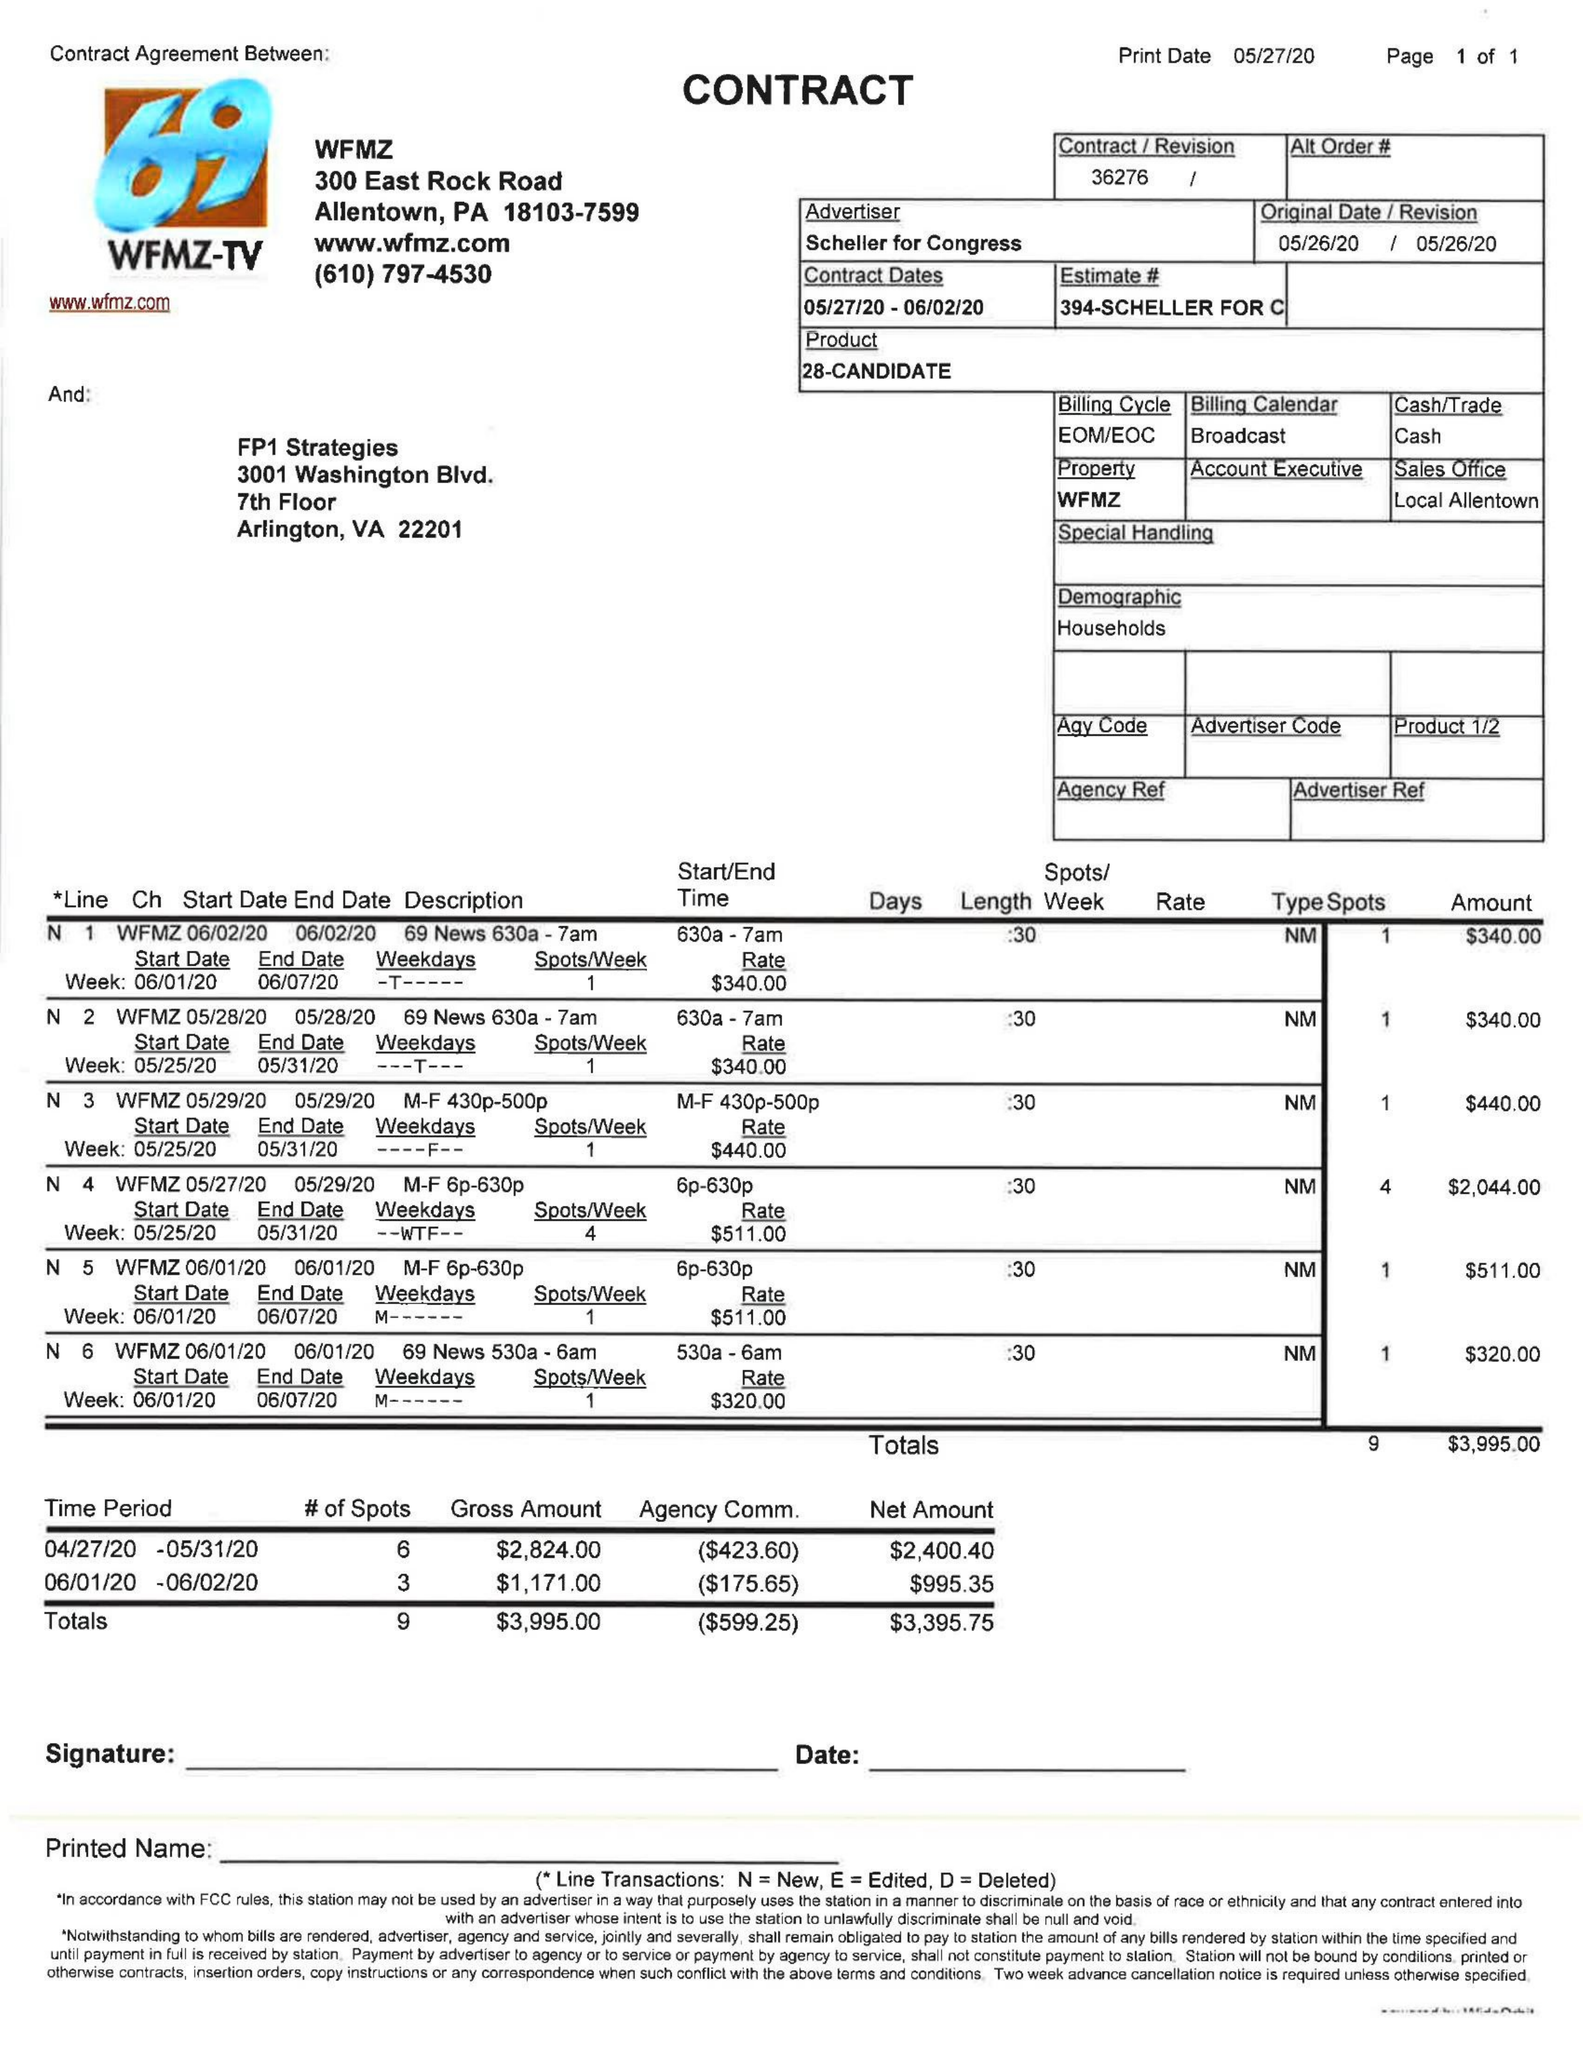What is the value for the flight_to?
Answer the question using a single word or phrase. 06/02/20 